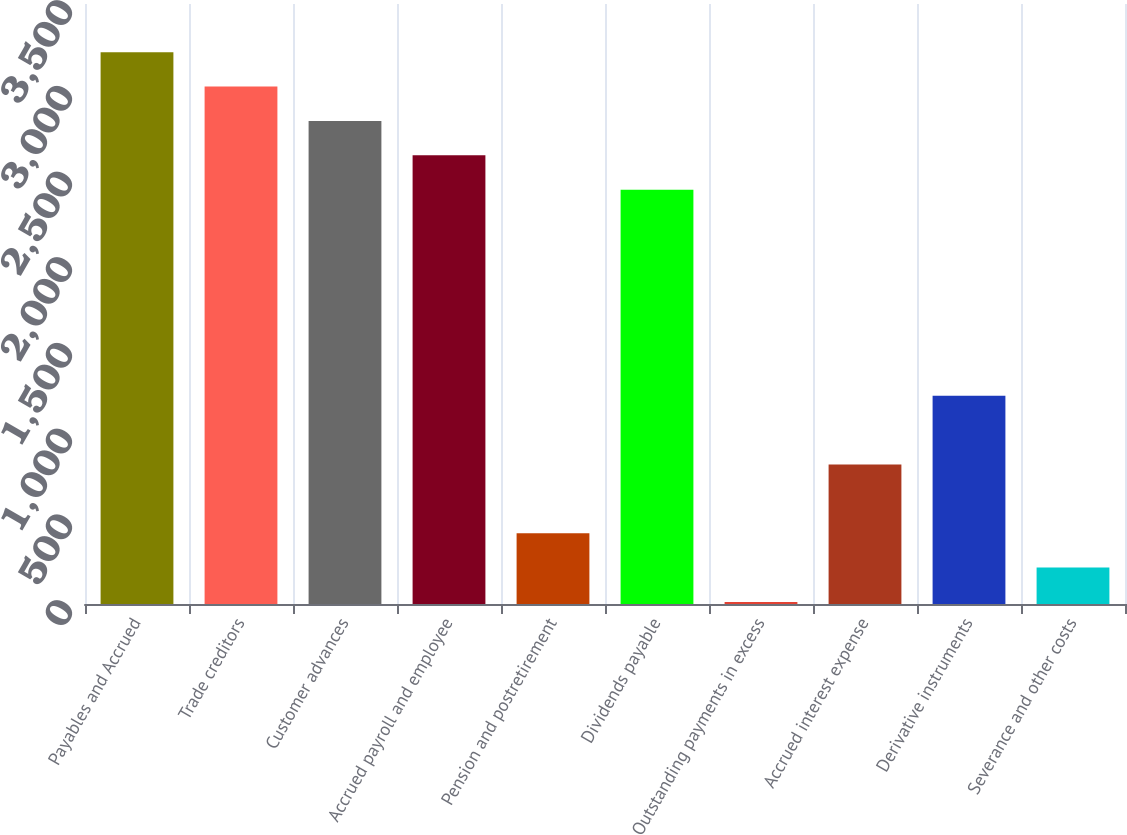Convert chart to OTSL. <chart><loc_0><loc_0><loc_500><loc_500><bar_chart><fcel>Payables and Accrued<fcel>Trade creditors<fcel>Customer advances<fcel>Accrued payroll and employee<fcel>Pension and postretirement<fcel>Dividends payable<fcel>Outstanding payments in excess<fcel>Accrued interest expense<fcel>Derivative instruments<fcel>Severance and other costs<nl><fcel>3218.46<fcel>3018.05<fcel>2817.64<fcel>2617.23<fcel>412.72<fcel>2416.82<fcel>11.9<fcel>813.54<fcel>1214.36<fcel>212.31<nl></chart> 